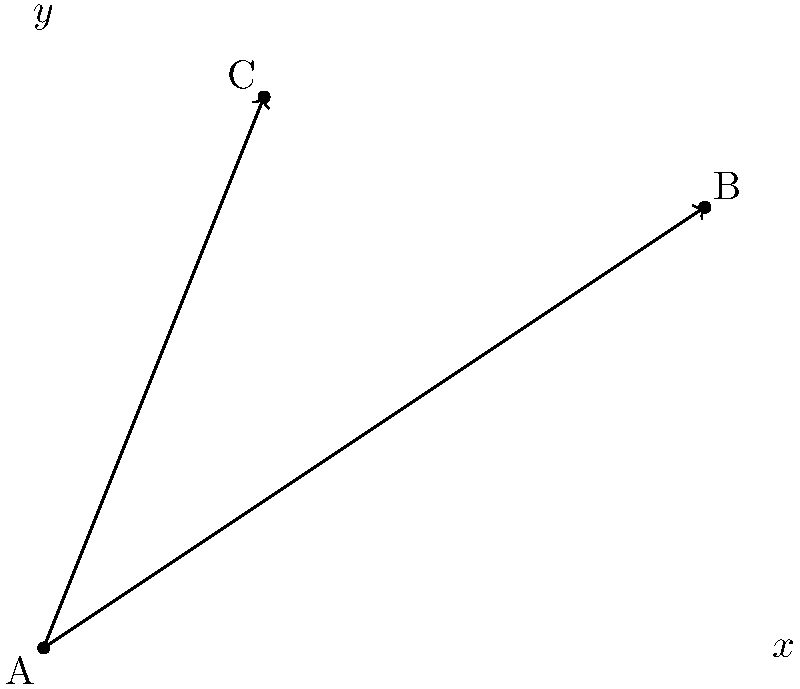In the coordinate plane shown above, line AB passes through points A(0,0) and B(6,4), while line AC passes through points A(0,0) and C(2,5). Calculate the acute angle $\theta$ formed between these two lines at their point of intersection A. To find the angle between two lines, we can use the dot product formula:

$$\cos \theta = \frac{\vec{u} \cdot \vec{v}}{|\vec{u}||\vec{v}|}$$

Where $\vec{u}$ and $\vec{v}$ are vectors representing the lines.

Step 1: Find vectors $\vec{u}$ and $\vec{v}$
$\vec{u} = \overrightarrow{AB} = (6-0, 4-0) = (6,4)$
$\vec{v} = \overrightarrow{AC} = (2-0, 5-0) = (2,5)$

Step 2: Calculate the dot product $\vec{u} \cdot \vec{v}$
$\vec{u} \cdot \vec{v} = 6(2) + 4(5) = 12 + 20 = 32$

Step 3: Calculate the magnitudes $|\vec{u}|$ and $|\vec{v}|$
$|\vec{u}| = \sqrt{6^2 + 4^2} = \sqrt{52}$
$|\vec{v}| = \sqrt{2^2 + 5^2} = \sqrt{29}$

Step 4: Apply the formula
$$\cos \theta = \frac{32}{\sqrt{52}\sqrt{29}}$$

Step 5: Find $\theta$ using inverse cosine
$$\theta = \arccos\left(\frac{32}{\sqrt{52}\sqrt{29}}\right)$$

Step 6: Calculate the result
$\theta \approx 0.2657$ radians or $15.23°$
Answer: $15.23°$ 